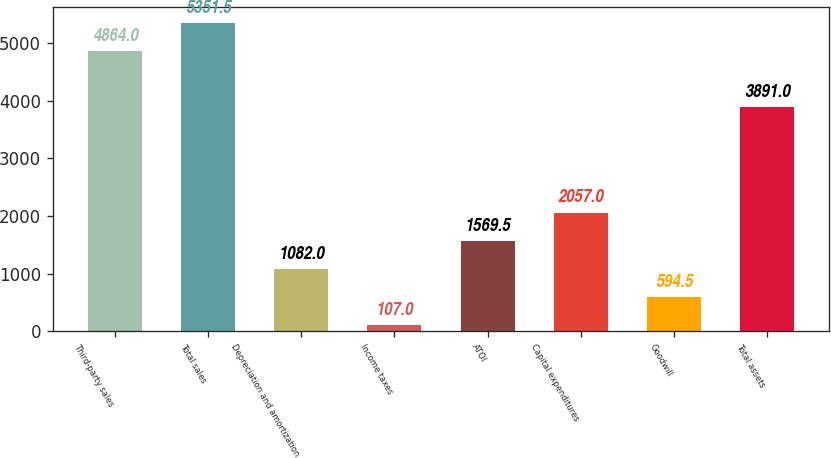<chart> <loc_0><loc_0><loc_500><loc_500><bar_chart><fcel>Third-party sales<fcel>Total sales<fcel>Depreciation and amortization<fcel>Income taxes<fcel>ATOI<fcel>Capital expenditures<fcel>Goodwill<fcel>Total assets<nl><fcel>4864<fcel>5351.5<fcel>1082<fcel>107<fcel>1569.5<fcel>2057<fcel>594.5<fcel>3891<nl></chart> 